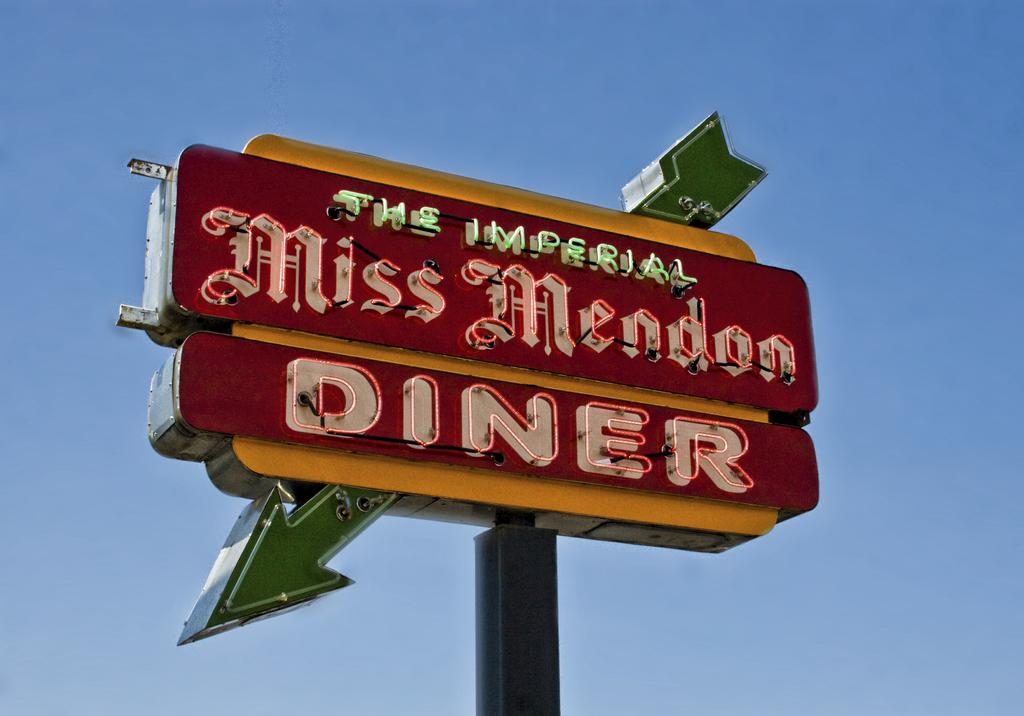Provide a one-sentence caption for the provided image. A red sign with a green arrow advertising The Imperial Miss Mendon Diner. 